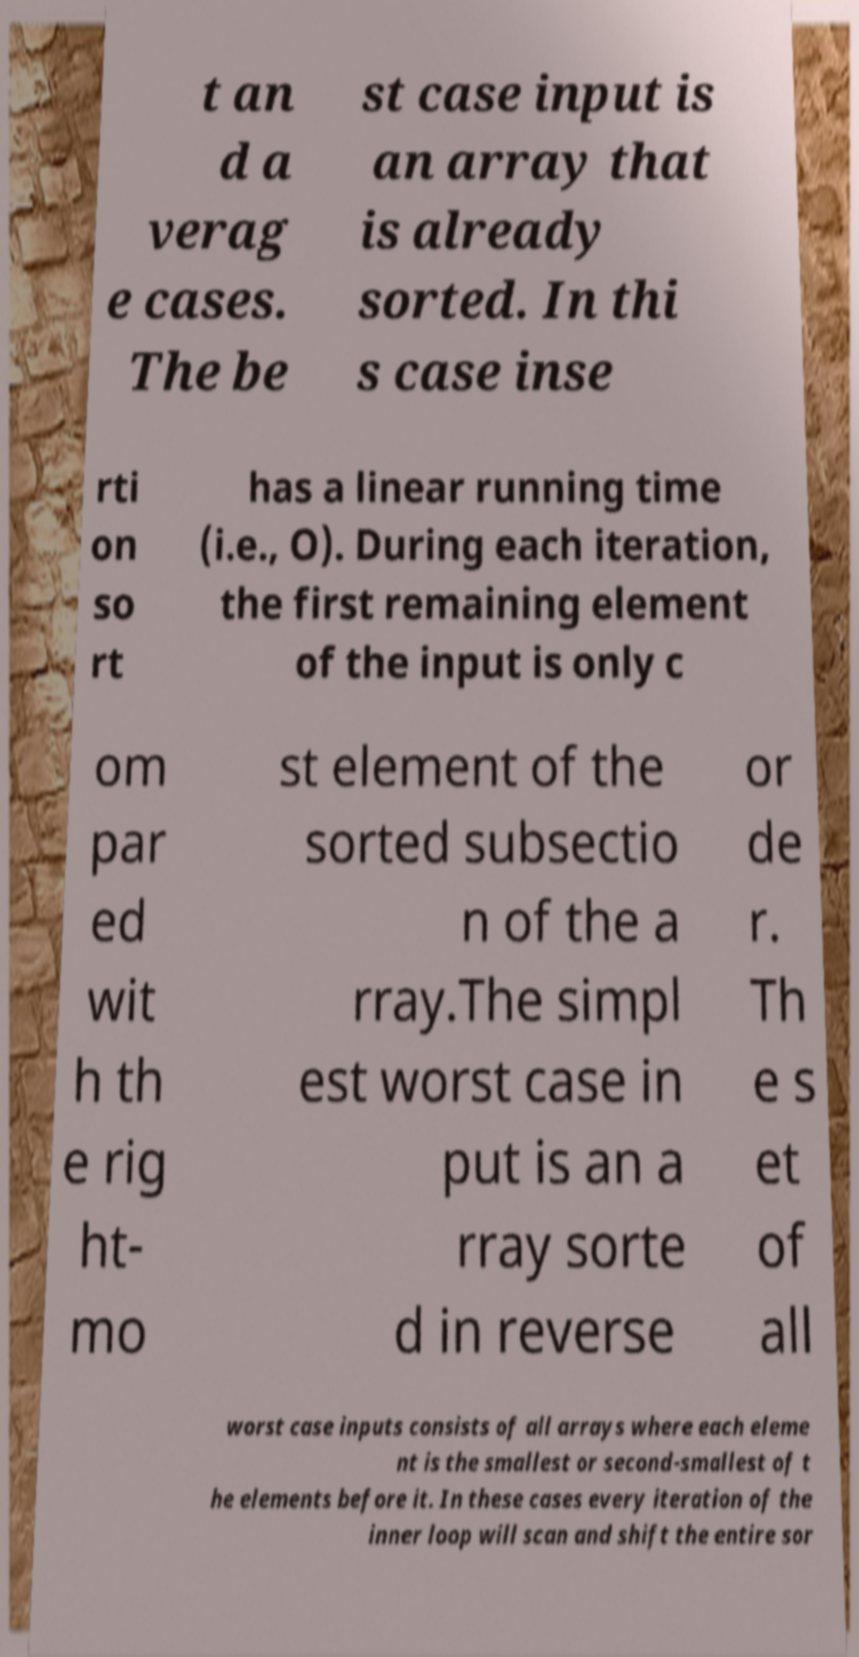For documentation purposes, I need the text within this image transcribed. Could you provide that? t an d a verag e cases. The be st case input is an array that is already sorted. In thi s case inse rti on so rt has a linear running time (i.e., O). During each iteration, the first remaining element of the input is only c om par ed wit h th e rig ht- mo st element of the sorted subsectio n of the a rray.The simpl est worst case in put is an a rray sorte d in reverse or de r. Th e s et of all worst case inputs consists of all arrays where each eleme nt is the smallest or second-smallest of t he elements before it. In these cases every iteration of the inner loop will scan and shift the entire sor 